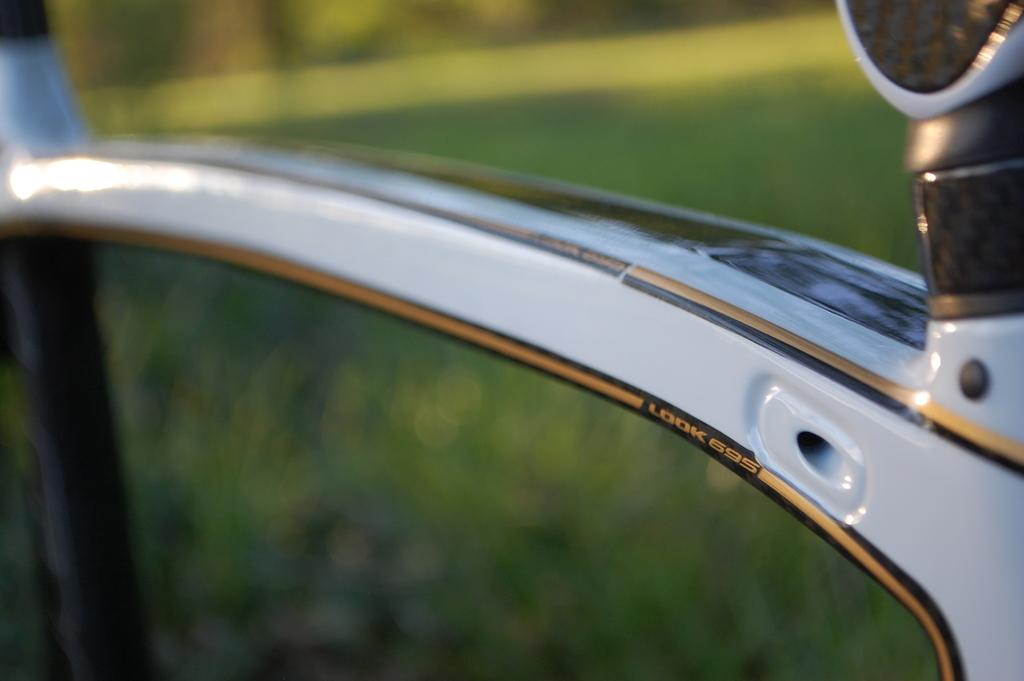What color is the object in the image? The object in the image is white in color. Can you describe the background of the image? The background of the image is blurred. What type of bun is being used by the team in the image? There is no team or bun present in the image. How many heads can be seen in the image? There is no head or indication of people in the image; only a white object and a blurred background are visible. 